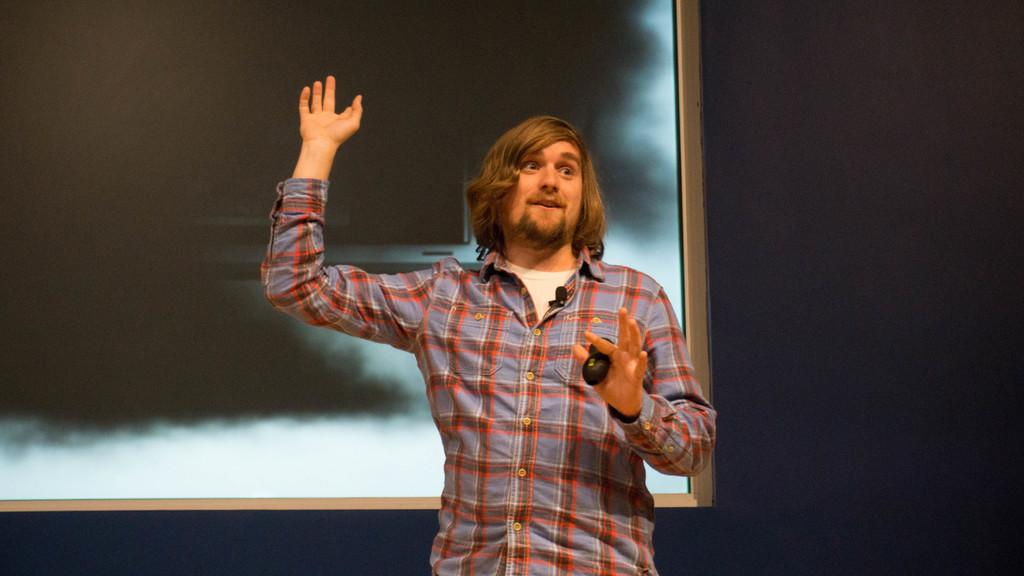Who or what is in the image? There is a person in the image. What is the person doing or interacting with in the image? The person is in front of a screen. What is the person wearing in the image? The person is wearing clothes. What type of substance is the person using to interact with the screen in the image? There is no indication in the image of any substance being used to interact with the screen. 